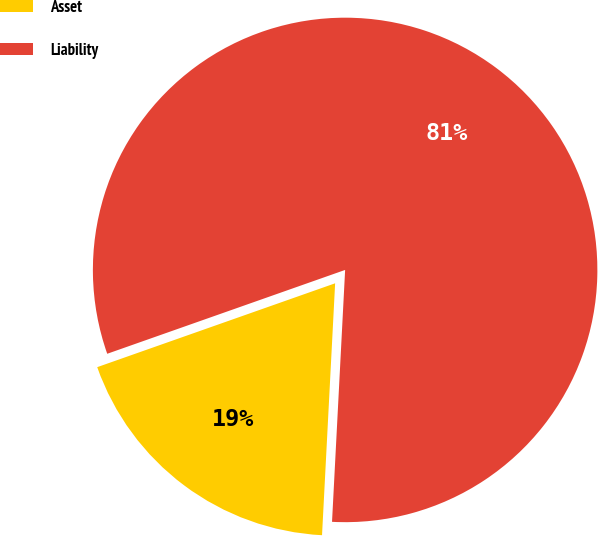Convert chart to OTSL. <chart><loc_0><loc_0><loc_500><loc_500><pie_chart><fcel>Asset<fcel>Liability<nl><fcel>18.78%<fcel>81.22%<nl></chart> 